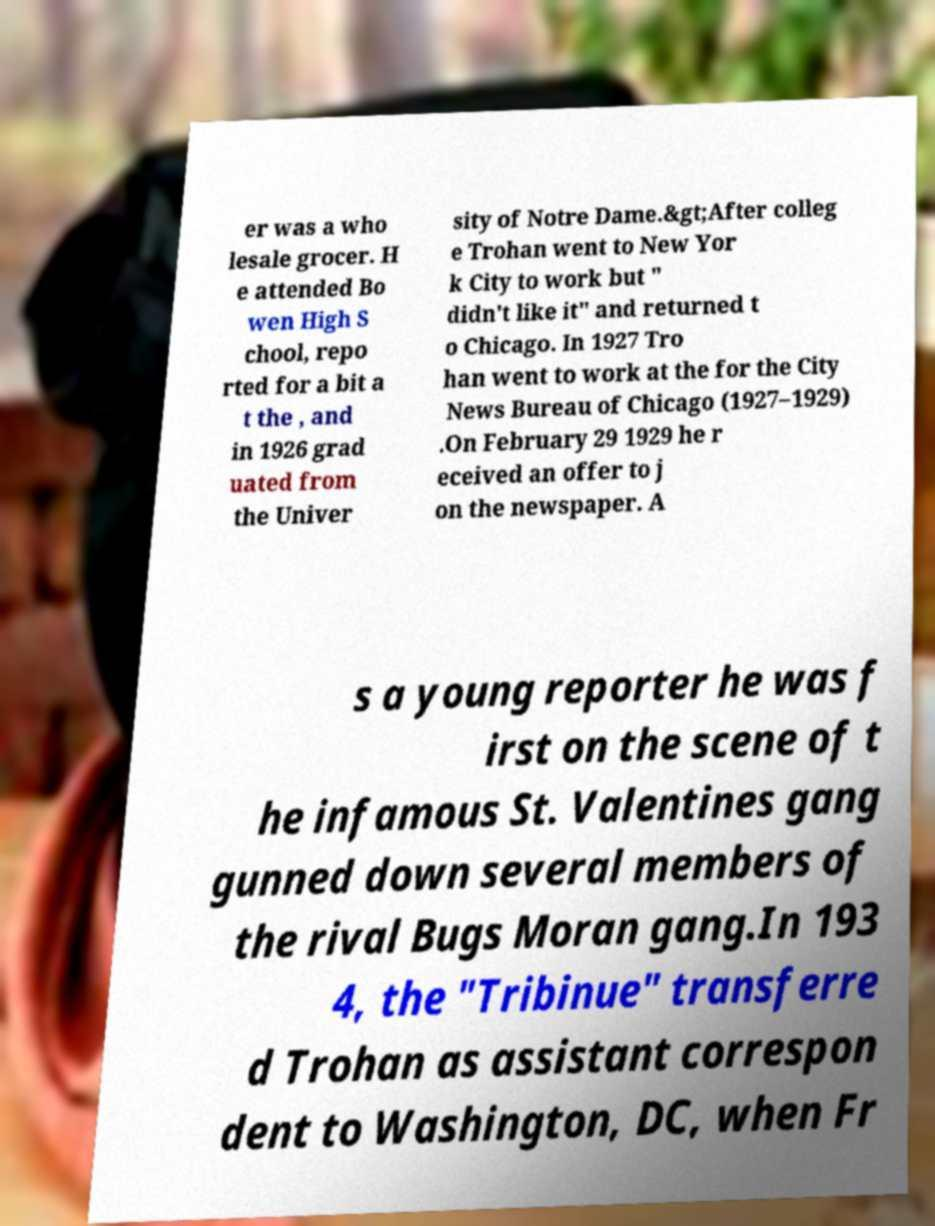Please identify and transcribe the text found in this image. er was a who lesale grocer. H e attended Bo wen High S chool, repo rted for a bit a t the , and in 1926 grad uated from the Univer sity of Notre Dame.&gt;After colleg e Trohan went to New Yor k City to work but " didn't like it" and returned t o Chicago. In 1927 Tro han went to work at the for the City News Bureau of Chicago (1927–1929) .On February 29 1929 he r eceived an offer to j on the newspaper. A s a young reporter he was f irst on the scene of t he infamous St. Valentines gang gunned down several members of the rival Bugs Moran gang.In 193 4, the "Tribinue" transferre d Trohan as assistant correspon dent to Washington, DC, when Fr 